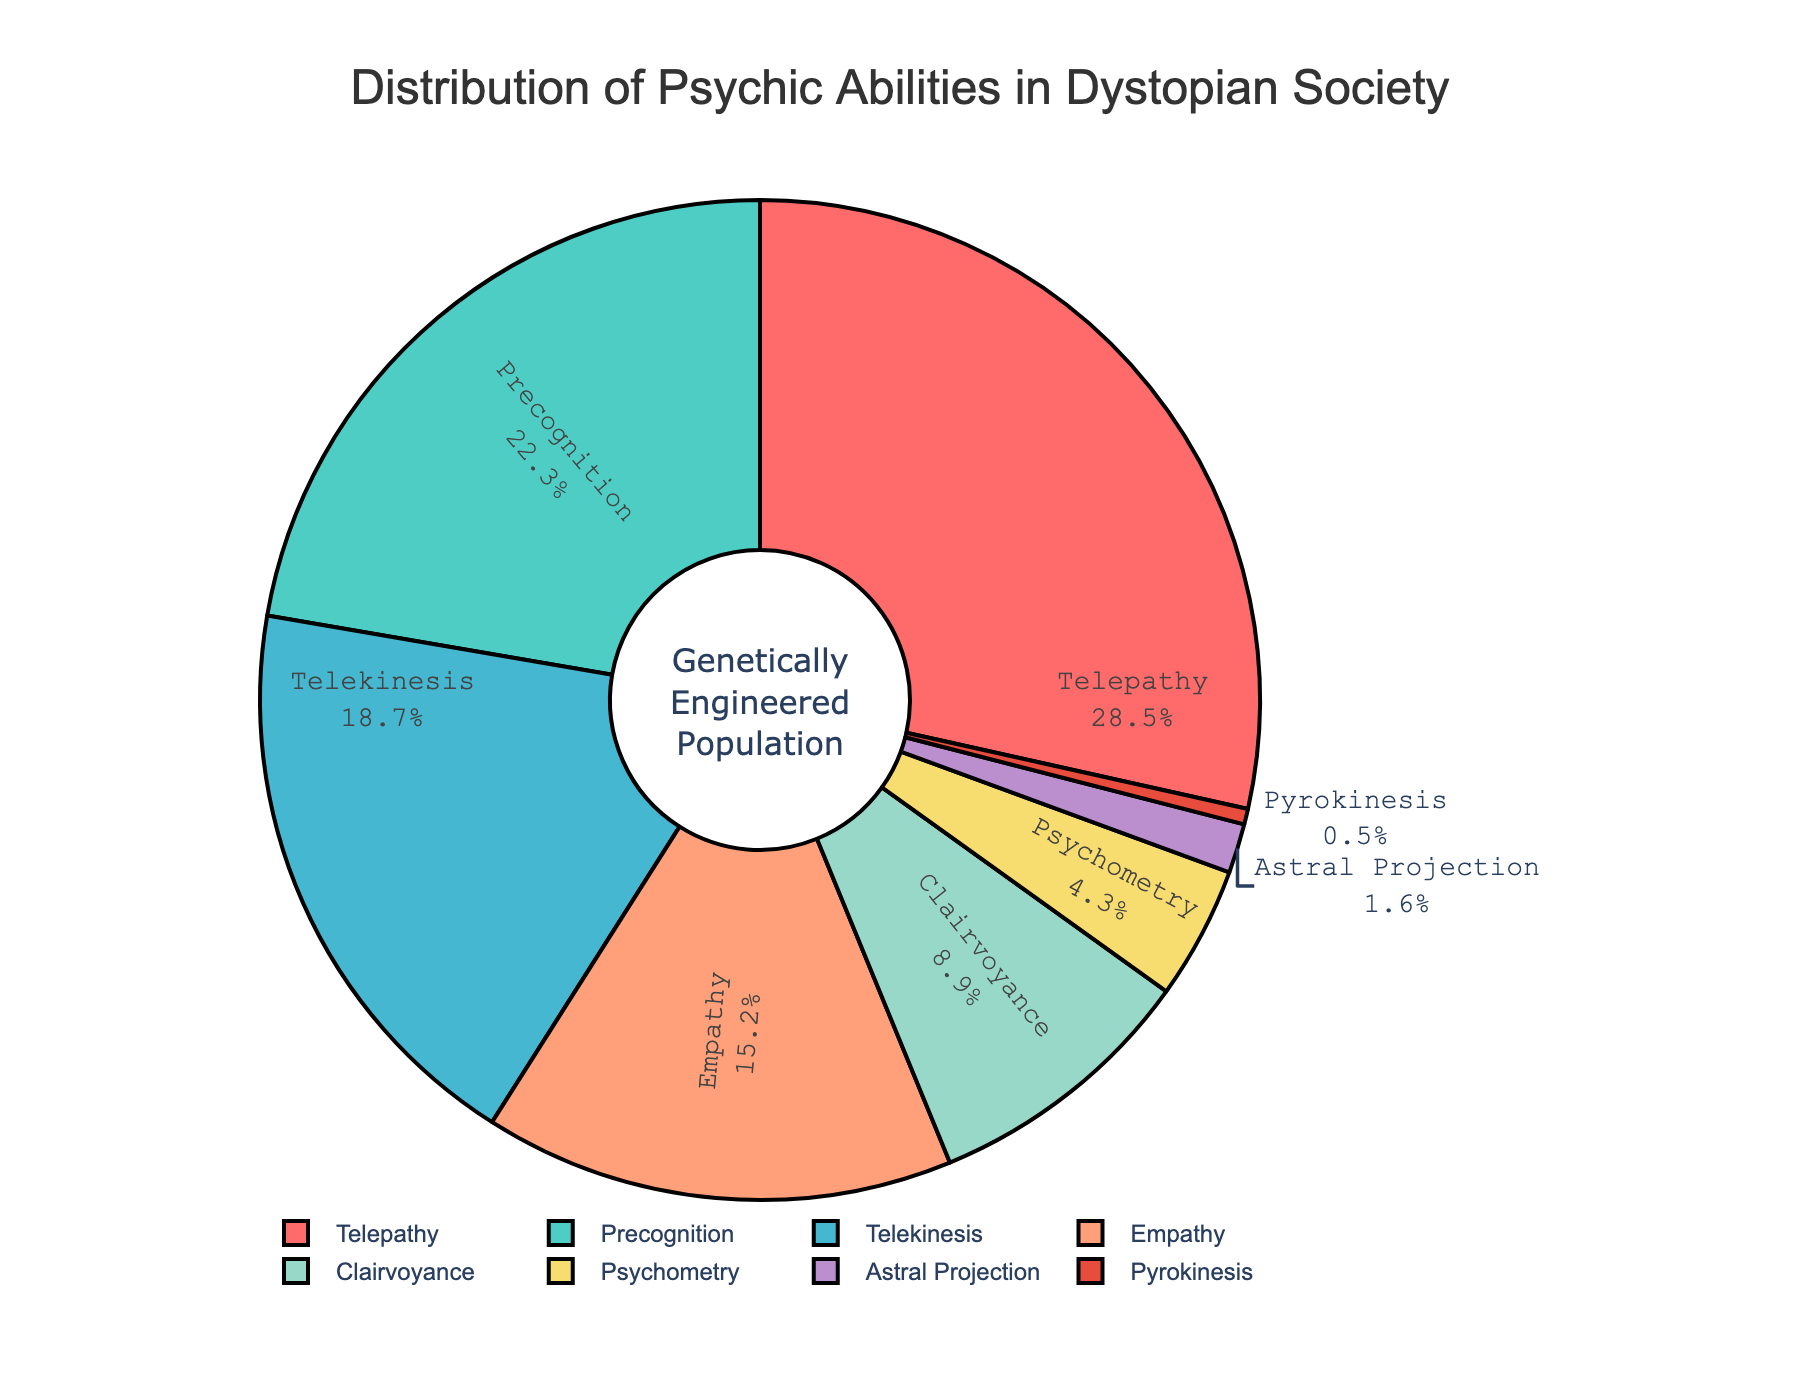Which psychic ability is most common in the population? The figure shows that Telepathy has the highest percentage among all the psychic abilities.
Answer: Telepathy What is the combined percentage of Empathy and Precognition? Add the percentages of Empathy (15.2%) and Precognition (22.3%) to get their combined percentage. 15.2 + 22.3 = 37.5%
Answer: 37.5% Which ability has the smallest percentage, and what is it? The figure shows that Pyrokinesis has the smallest percentage among all the abilities, which is 0.5%.
Answer: Pyrokinesis, 0.5% How does the percentage of Telekinesis compare to Astral Projection? The figure shows that the percentage of Telekinesis (18.7%) is significantly higher than Astral Projection (1.6%).
Answer: Telekinesis is higher What is the difference between the percentages of Telepathy and Clairvoyance? Subtract the percentage of Clairvoyance (8.9%) from the percentage of Telepathy (28.5%). 28.5 - 8.9 = 19.6%
Answer: 19.6% Which abilities make up less than 5% of the population? The figure shows Psychometry (4.3%), Astral Projection (1.6%), and Pyrokinesis (0.5%) are all less than 5%.
Answer: Psychometry, Astral Projection, Pyrokinesis What percentage does Telepathy and Telekinesis account for together? Add the percentages of Telepathy (28.5%) and Telekinesis (18.7%) to get the combined percentage. 28.5 + 18.7 = 47.2%
Answer: 47.2% Which section of the pie chart is orange, and what percentage does it represent? The figure shows that the section for Telepathy is marked in orange, representing 28.5%.
Answer: Telepathy, 28.5% What is the average percentage of all psychic abilities? Add all the percentages (28.5 + 22.3 + 18.7 + 15.2 + 8.9 + 4.3 + 1.6 + 0.5) to get the total, then divide by the number of abilities (8) to get the average. (28.5 + 22.3 + 18.7 + 15.2 + 8.9 + 4.3 + 1.6 + 0.5) / 8 = 100 / 8 = 12.5
Answer: 12.5% What percentage more is Empathy compared to Astral Projection? Subtract the percentage of Astral Projection (1.6%) from the percentage of Empathy (15.2%) to find the difference. 15.2 - 1.6 = 13.6%.
Answer: 13.6% 